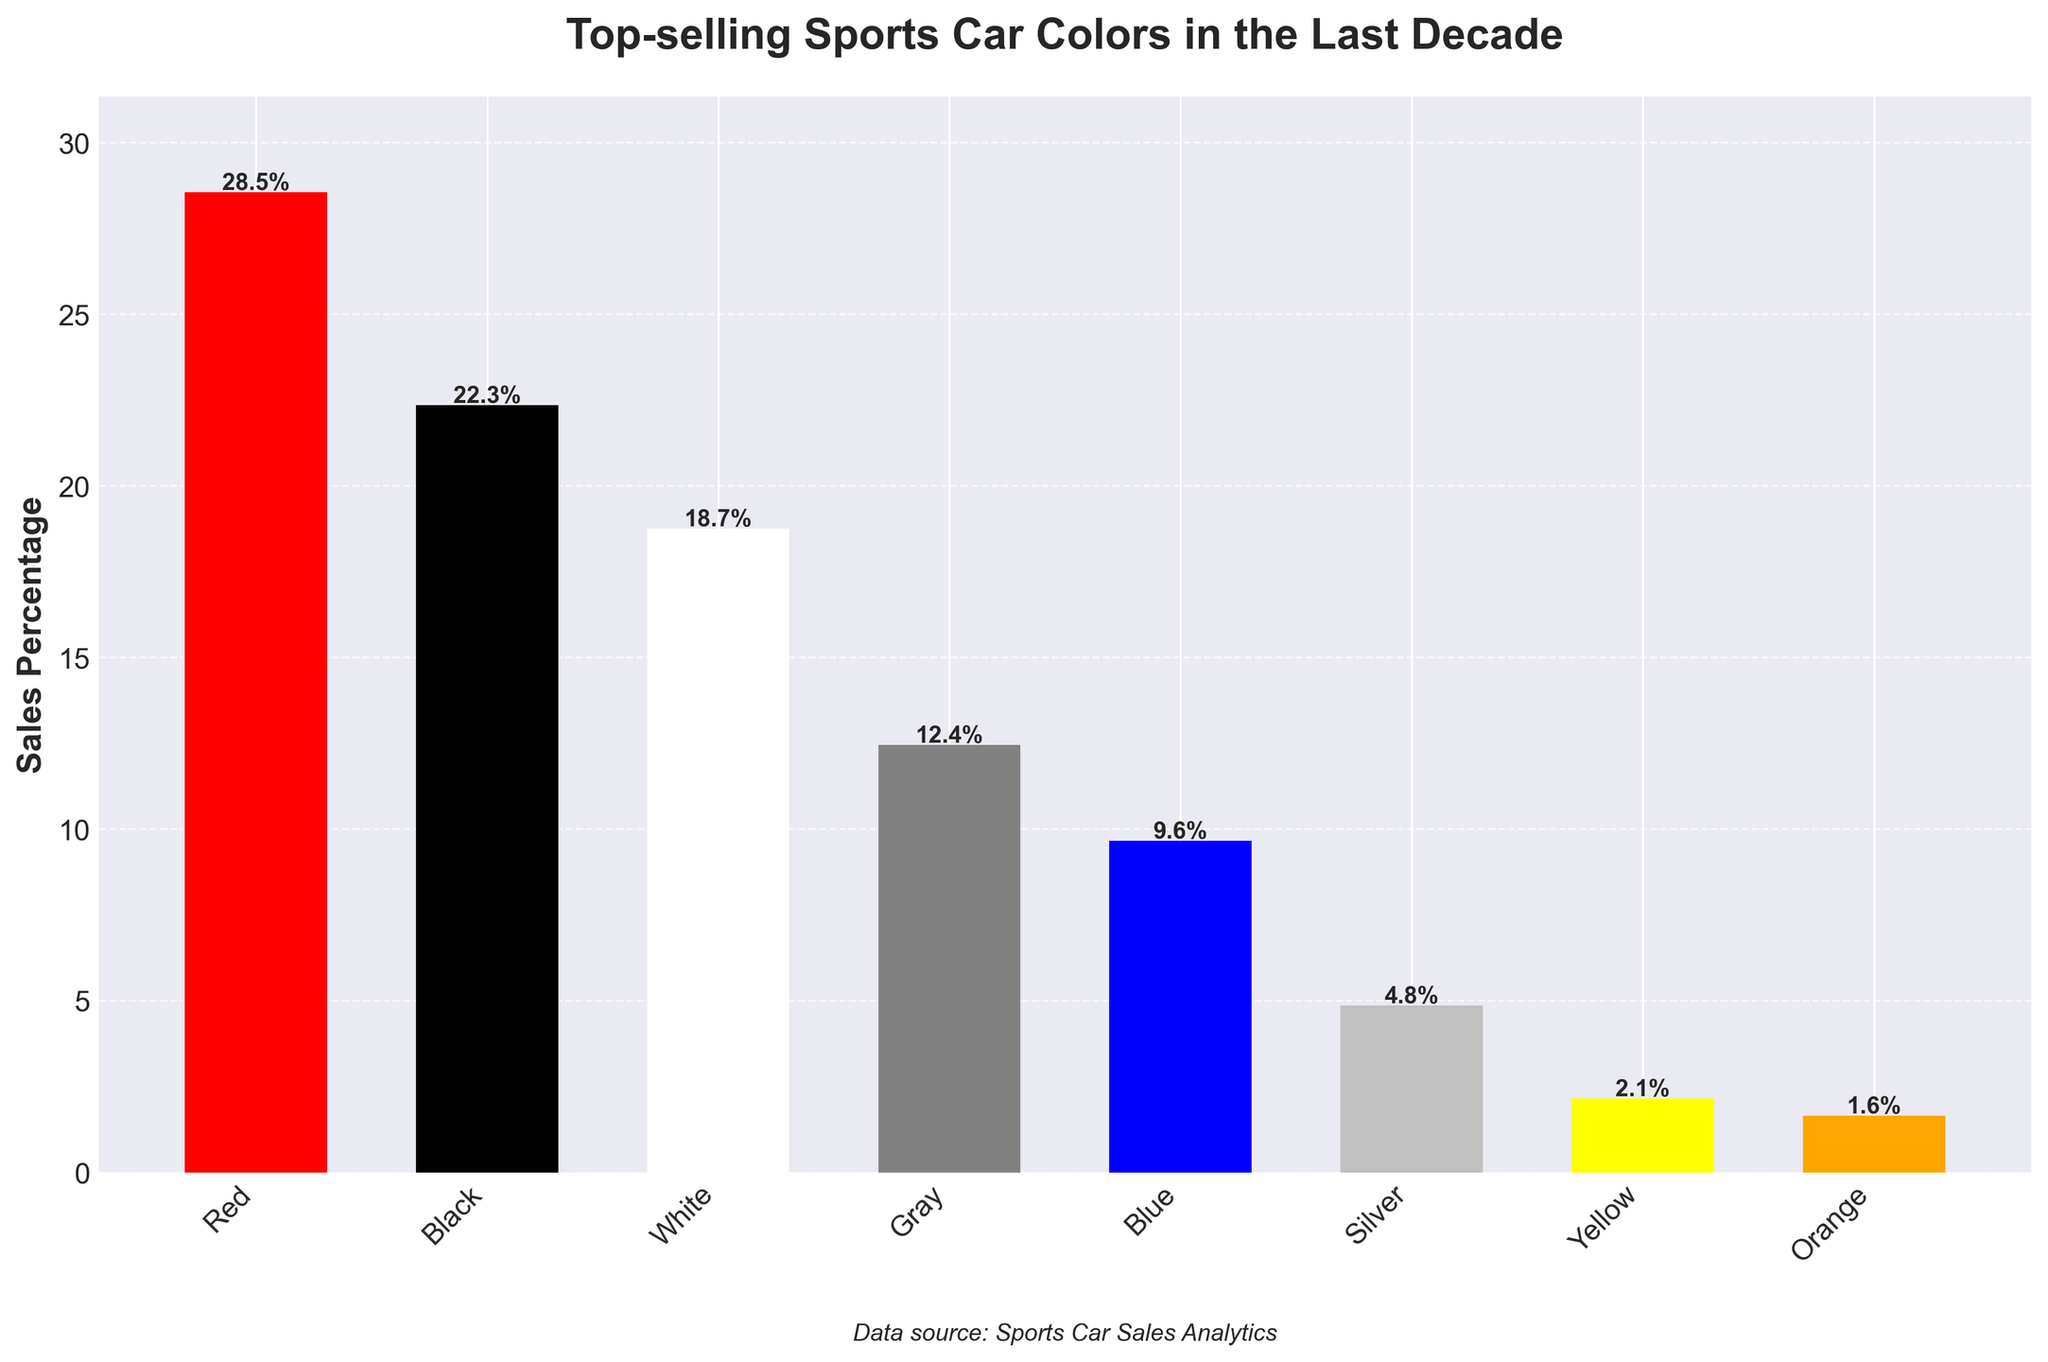What is the most popular color for top-selling sports cars in the last decade? The bar representing the color red is the tallest on the chart, indicating the highest sales percentage.
Answer: Red Which color has a sales percentage closest to 20%? The color black has a sales percentage of 22.3%, which is closest to 20%.
Answer: Black How much more popular is red compared to blue? The sales percentage for red is 28.5%, and for blue, it is 9.6%. The difference is 28.5% - 9.6% = 18.9%.
Answer: 18.9% What is the combined sales percentage for gray and silver? The sales percentages for gray and silver are 12.4% and 4.8%, respectively. The combined percentage is 12.4% + 4.8% = 17.2%.
Answer: 17.2% Which color has the least sales percentage? The bar representing the color orange is the shortest on the chart, indicating the lowest sales percentage.
Answer: Orange How does the sales percentage of black compare to yellow? The sales percentage for black is 22.3%, whereas for yellow, it is 2.1%. Black's sales percentage is significantly higher.
Answer: Black > Yellow Are the sales percentages for white and gray combined greater than that for red? The combined sales percentage for white and gray is 18.7% + 12.4% = 31.1%. This is greater than the sales percentage for red, which is 28.5%.
Answer: Yes Which two colors have the smallest difference in sales percentage? The sales percentages for silver and yellow are 4.8% and 2.1%, respectively. The difference is 4.8% - 2.1% = 2.7%, which is the smallest difference among all pairs.
Answer: Silver and Yellow What is the average sales percentage for all the colors displayed? Sum of the percentages for all colors is 28.5 + 22.3 + 18.7 + 12.4 + 9.6 + 4.8 + 2.1 + 1.6 = 100. The average is 100 / 8 = 12.5%.
Answer: 12.5% 